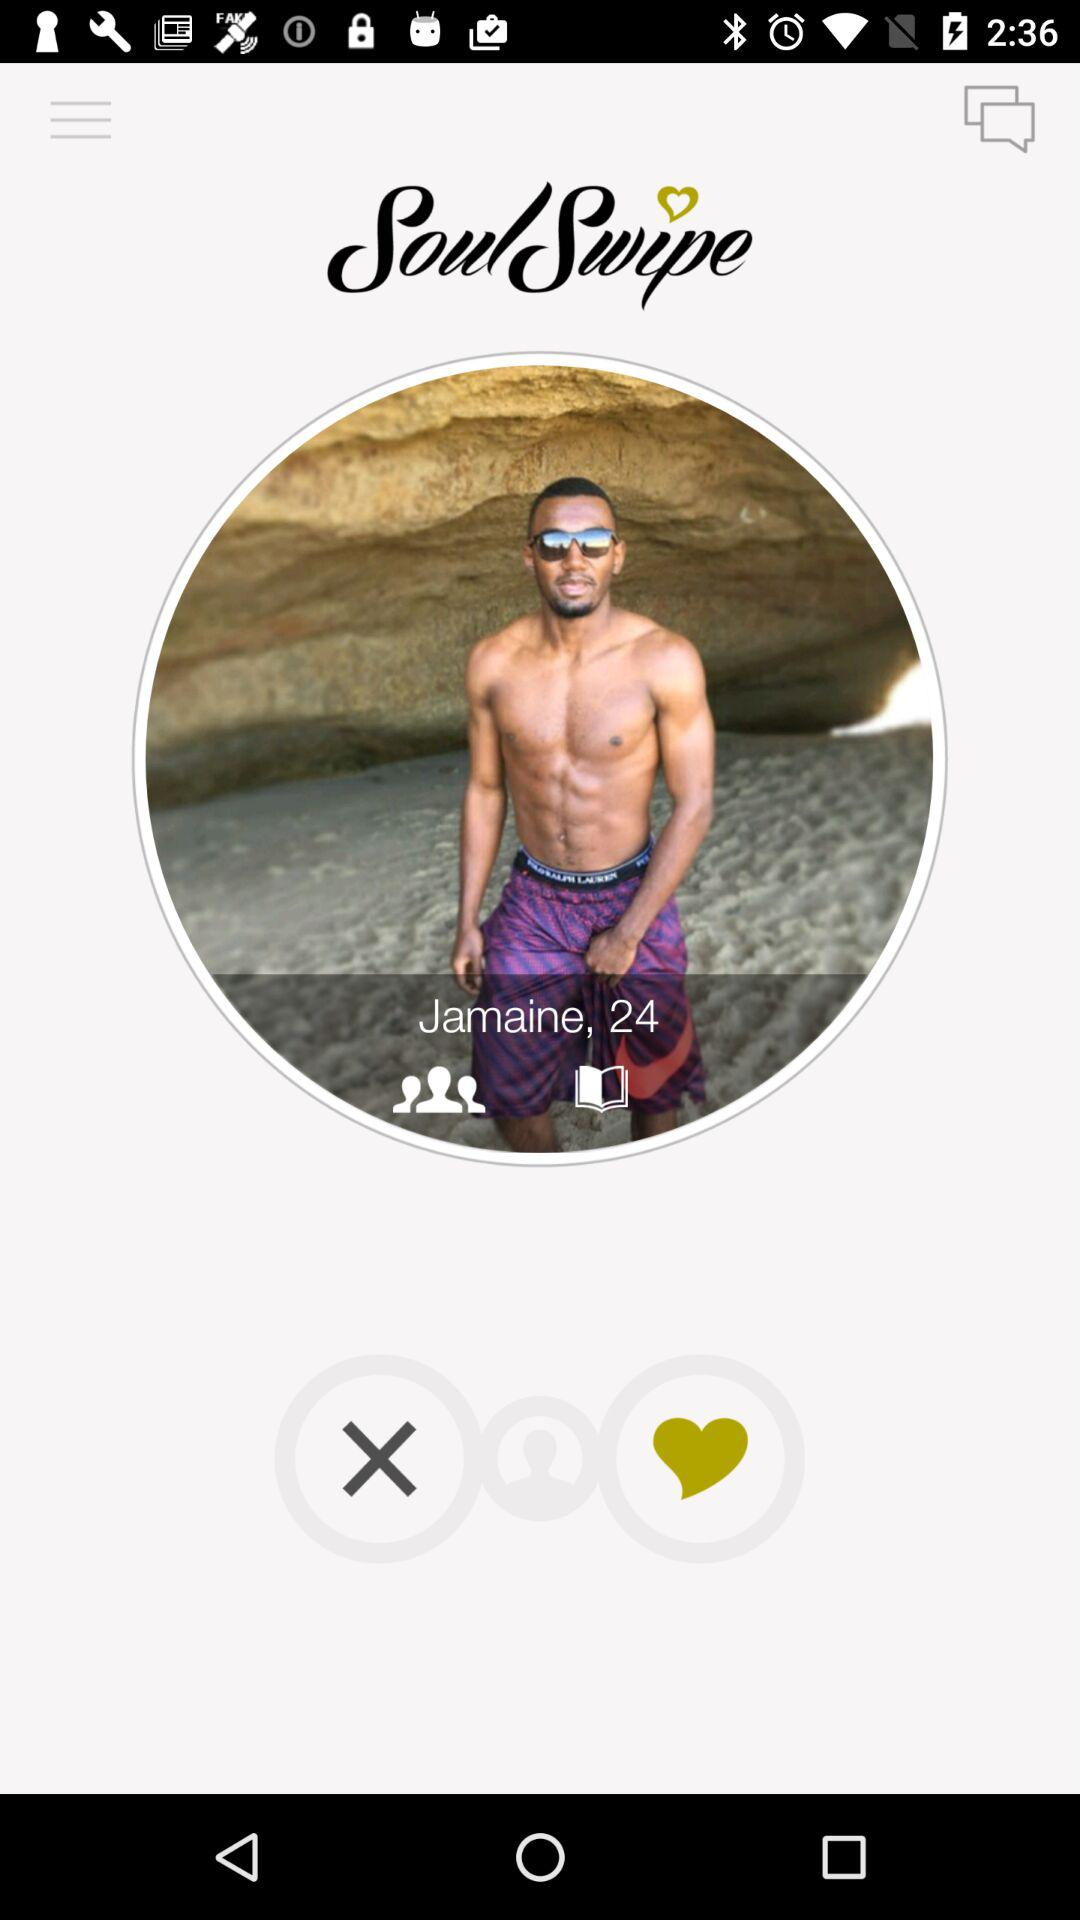What is the age? The age is 24. 